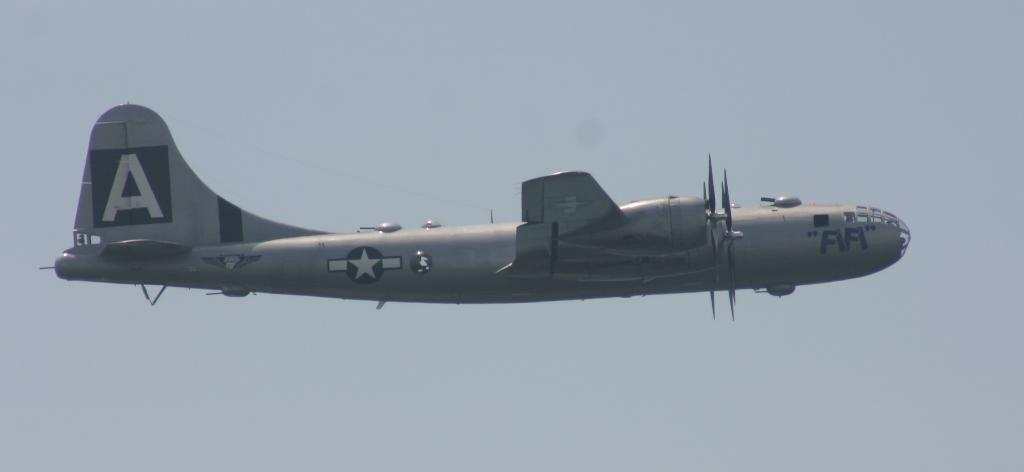What is the main subject of the image? The main subject of the image is an aircraft. What is the aircraft doing in the image? The aircraft is flying in the image. What can be seen in the background of the image? The sky is visible at the top of the image. What type of curtain is hanging in the aircraft in the image? There is no curtain present in the image; it features an aircraft flying in the sky. 